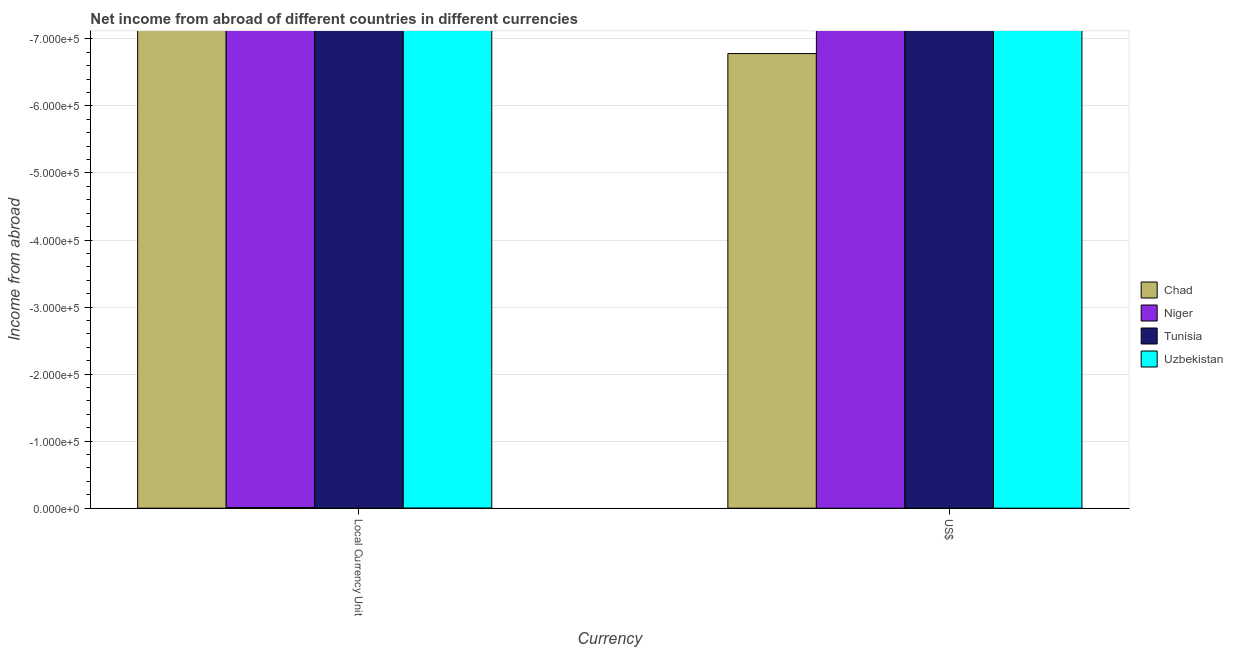Are the number of bars on each tick of the X-axis equal?
Your answer should be compact. Yes. How many bars are there on the 1st tick from the left?
Provide a succinct answer. 0. How many bars are there on the 1st tick from the right?
Your response must be concise. 0. What is the label of the 2nd group of bars from the left?
Make the answer very short. US$. Across all countries, what is the minimum income from abroad in us$?
Your answer should be compact. 0. What is the difference between the income from abroad in constant 2005 us$ in Tunisia and the income from abroad in us$ in Niger?
Give a very brief answer. 0. In how many countries, is the income from abroad in us$ greater than -280000 units?
Provide a short and direct response. 0. Does the graph contain any zero values?
Ensure brevity in your answer.  Yes. What is the title of the graph?
Give a very brief answer. Net income from abroad of different countries in different currencies. Does "Kenya" appear as one of the legend labels in the graph?
Give a very brief answer. No. What is the label or title of the X-axis?
Provide a short and direct response. Currency. What is the label or title of the Y-axis?
Ensure brevity in your answer.  Income from abroad. What is the Income from abroad in Niger in Local Currency Unit?
Ensure brevity in your answer.  0. What is the Income from abroad of Uzbekistan in Local Currency Unit?
Offer a terse response. 0. What is the Income from abroad of Chad in US$?
Your answer should be compact. 0. What is the Income from abroad of Tunisia in US$?
Make the answer very short. 0. What is the Income from abroad of Uzbekistan in US$?
Your answer should be very brief. 0. What is the average Income from abroad of Tunisia per Currency?
Offer a terse response. 0. What is the average Income from abroad in Uzbekistan per Currency?
Offer a very short reply. 0. 